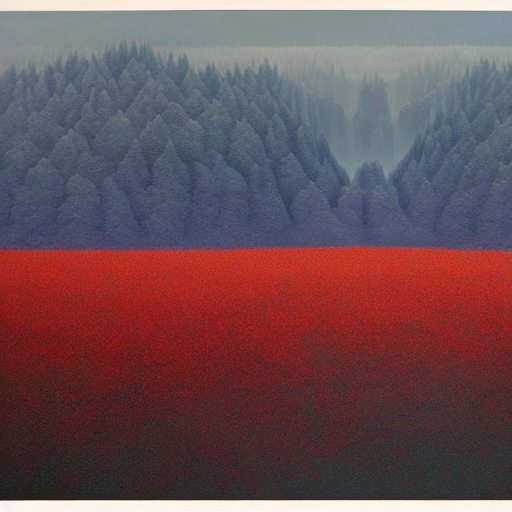What kind of emotions does this image evoke? The contrasting colors and the misty veil over the forest create a serene, yet slightly mysterious atmosphere. The red foreground may invoke feelings of awe due to its vibrancy, whereas the softness of the mist-covered trees could provide a sense of calm. 